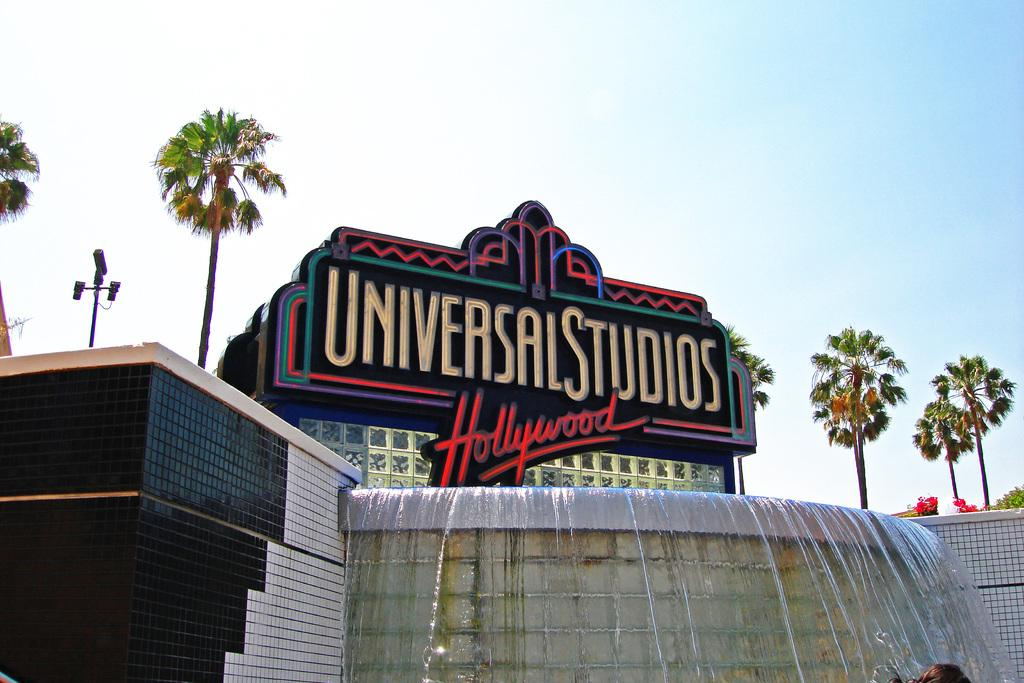What is the main object in the image that displays names? There is a name display board in the image. Where is the name display board located? on the image? What can be seen in the background of the image? There is a building and trees in the background of the image. What position does the account hold in the image? There is no account mentioned or depicted in the image. How does the rub affect the name display board in the image? There is no rub present in the image, so its effect cannot be determined. 